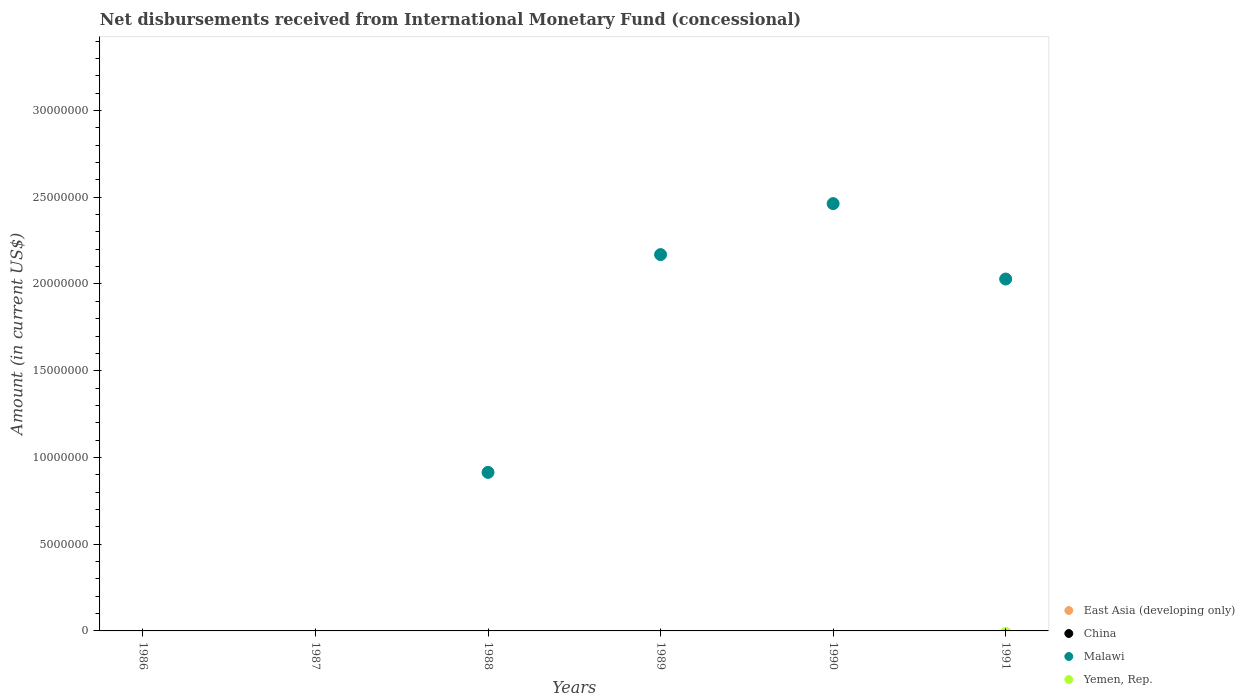How many different coloured dotlines are there?
Your answer should be very brief. 1. Is the number of dotlines equal to the number of legend labels?
Provide a short and direct response. No. What is the amount of disbursements received from International Monetary Fund in Malawi in 1989?
Make the answer very short. 2.17e+07. Across all years, what is the minimum amount of disbursements received from International Monetary Fund in China?
Offer a very short reply. 0. In which year was the amount of disbursements received from International Monetary Fund in Malawi maximum?
Make the answer very short. 1990. What is the total amount of disbursements received from International Monetary Fund in Yemen, Rep. in the graph?
Offer a very short reply. 0. What is the average amount of disbursements received from International Monetary Fund in Malawi per year?
Keep it short and to the point. 1.26e+07. What is the difference between the highest and the second highest amount of disbursements received from International Monetary Fund in Malawi?
Your answer should be very brief. 2.94e+06. What is the difference between the highest and the lowest amount of disbursements received from International Monetary Fund in Malawi?
Your answer should be very brief. 2.46e+07. In how many years, is the amount of disbursements received from International Monetary Fund in Malawi greater than the average amount of disbursements received from International Monetary Fund in Malawi taken over all years?
Your answer should be very brief. 3. Is it the case that in every year, the sum of the amount of disbursements received from International Monetary Fund in Yemen, Rep. and amount of disbursements received from International Monetary Fund in East Asia (developing only)  is greater than the amount of disbursements received from International Monetary Fund in China?
Your answer should be compact. No. Does the amount of disbursements received from International Monetary Fund in East Asia (developing only) monotonically increase over the years?
Make the answer very short. No. Is the amount of disbursements received from International Monetary Fund in East Asia (developing only) strictly greater than the amount of disbursements received from International Monetary Fund in China over the years?
Make the answer very short. No. Is the amount of disbursements received from International Monetary Fund in East Asia (developing only) strictly less than the amount of disbursements received from International Monetary Fund in Malawi over the years?
Offer a terse response. Yes. How many dotlines are there?
Your answer should be compact. 1. How many years are there in the graph?
Offer a terse response. 6. What is the difference between two consecutive major ticks on the Y-axis?
Offer a terse response. 5.00e+06. How many legend labels are there?
Keep it short and to the point. 4. What is the title of the graph?
Provide a succinct answer. Net disbursements received from International Monetary Fund (concessional). Does "Vanuatu" appear as one of the legend labels in the graph?
Your answer should be compact. No. What is the Amount (in current US$) in China in 1986?
Ensure brevity in your answer.  0. What is the Amount (in current US$) in China in 1987?
Give a very brief answer. 0. What is the Amount (in current US$) in China in 1988?
Offer a very short reply. 0. What is the Amount (in current US$) of Malawi in 1988?
Keep it short and to the point. 9.14e+06. What is the Amount (in current US$) of China in 1989?
Your answer should be very brief. 0. What is the Amount (in current US$) of Malawi in 1989?
Your response must be concise. 2.17e+07. What is the Amount (in current US$) of Yemen, Rep. in 1989?
Provide a short and direct response. 0. What is the Amount (in current US$) of East Asia (developing only) in 1990?
Your response must be concise. 0. What is the Amount (in current US$) in Malawi in 1990?
Ensure brevity in your answer.  2.46e+07. What is the Amount (in current US$) in China in 1991?
Your answer should be compact. 0. What is the Amount (in current US$) in Malawi in 1991?
Your answer should be very brief. 2.03e+07. What is the Amount (in current US$) of Yemen, Rep. in 1991?
Give a very brief answer. 0. Across all years, what is the maximum Amount (in current US$) in Malawi?
Offer a terse response. 2.46e+07. Across all years, what is the minimum Amount (in current US$) in Malawi?
Provide a succinct answer. 0. What is the total Amount (in current US$) of China in the graph?
Keep it short and to the point. 0. What is the total Amount (in current US$) in Malawi in the graph?
Make the answer very short. 7.58e+07. What is the total Amount (in current US$) of Yemen, Rep. in the graph?
Give a very brief answer. 0. What is the difference between the Amount (in current US$) in Malawi in 1988 and that in 1989?
Your answer should be compact. -1.26e+07. What is the difference between the Amount (in current US$) of Malawi in 1988 and that in 1990?
Keep it short and to the point. -1.55e+07. What is the difference between the Amount (in current US$) in Malawi in 1988 and that in 1991?
Offer a very short reply. -1.11e+07. What is the difference between the Amount (in current US$) of Malawi in 1989 and that in 1990?
Provide a succinct answer. -2.94e+06. What is the difference between the Amount (in current US$) in Malawi in 1989 and that in 1991?
Keep it short and to the point. 1.41e+06. What is the difference between the Amount (in current US$) of Malawi in 1990 and that in 1991?
Ensure brevity in your answer.  4.35e+06. What is the average Amount (in current US$) in East Asia (developing only) per year?
Make the answer very short. 0. What is the average Amount (in current US$) in China per year?
Keep it short and to the point. 0. What is the average Amount (in current US$) of Malawi per year?
Your response must be concise. 1.26e+07. What is the average Amount (in current US$) of Yemen, Rep. per year?
Give a very brief answer. 0. What is the ratio of the Amount (in current US$) in Malawi in 1988 to that in 1989?
Give a very brief answer. 0.42. What is the ratio of the Amount (in current US$) of Malawi in 1988 to that in 1990?
Provide a succinct answer. 0.37. What is the ratio of the Amount (in current US$) in Malawi in 1988 to that in 1991?
Offer a terse response. 0.45. What is the ratio of the Amount (in current US$) in Malawi in 1989 to that in 1990?
Offer a terse response. 0.88. What is the ratio of the Amount (in current US$) of Malawi in 1989 to that in 1991?
Provide a succinct answer. 1.07. What is the ratio of the Amount (in current US$) in Malawi in 1990 to that in 1991?
Your answer should be very brief. 1.21. What is the difference between the highest and the second highest Amount (in current US$) in Malawi?
Offer a very short reply. 2.94e+06. What is the difference between the highest and the lowest Amount (in current US$) in Malawi?
Offer a very short reply. 2.46e+07. 